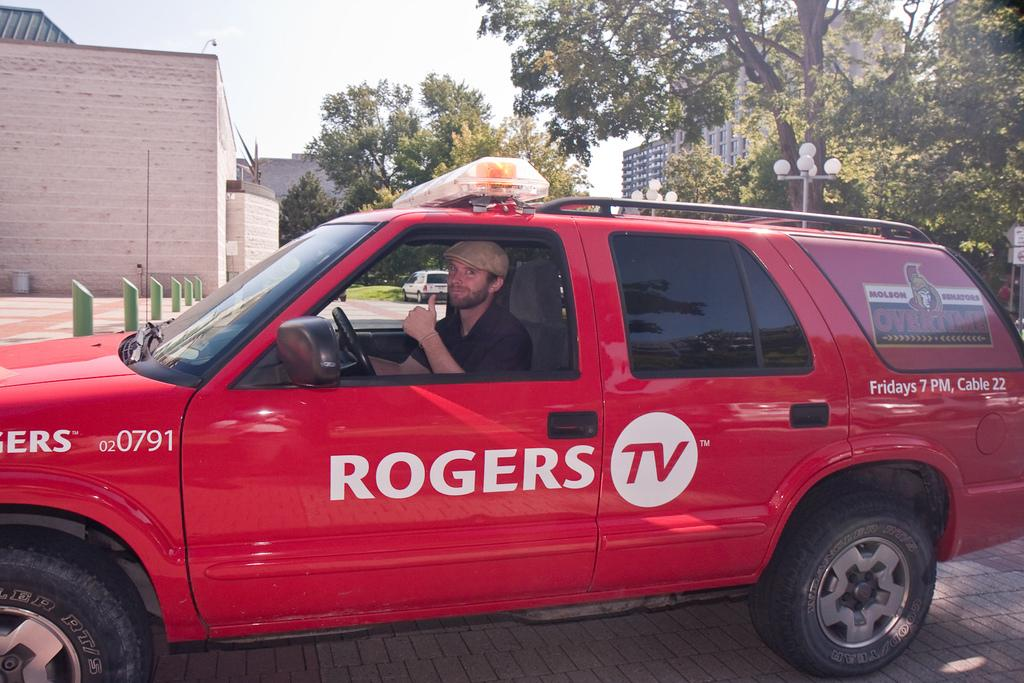What can be seen at the top of the image? The sky is visible at the top of the image. What type of structures are present in the image? There are buildings and a house in the image. What other natural elements can be seen in the image? There are trees in the image. What artificial elements are present in the image? There are lights in the image. What is the man inside the car doing? The man is showing his thumb finger. What is the man wearing on his head? The man is wearing a cap. How many dimes can be seen on the bed in the image? There is no bed or dimes present in the image. What type of paper is the man holding in the image? There is no paper present in the image; the man is showing his thumb finger. 